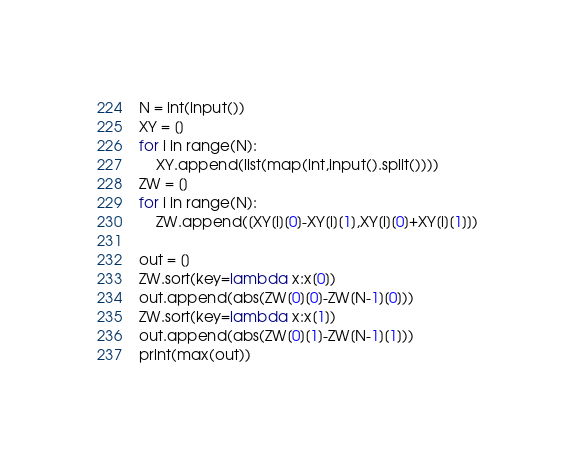Convert code to text. <code><loc_0><loc_0><loc_500><loc_500><_Python_>N = int(input())
XY = []
for i in range(N):
    XY.append(list(map(int,input().split())))
ZW = []
for i in range(N):
    ZW.append([XY[i][0]-XY[i][1],XY[i][0]+XY[i][1]])

out = []
ZW.sort(key=lambda x:x[0])
out.append(abs(ZW[0][0]-ZW[N-1][0]))
ZW.sort(key=lambda x:x[1])
out.append(abs(ZW[0][1]-ZW[N-1][1]))
print(max(out))
</code> 